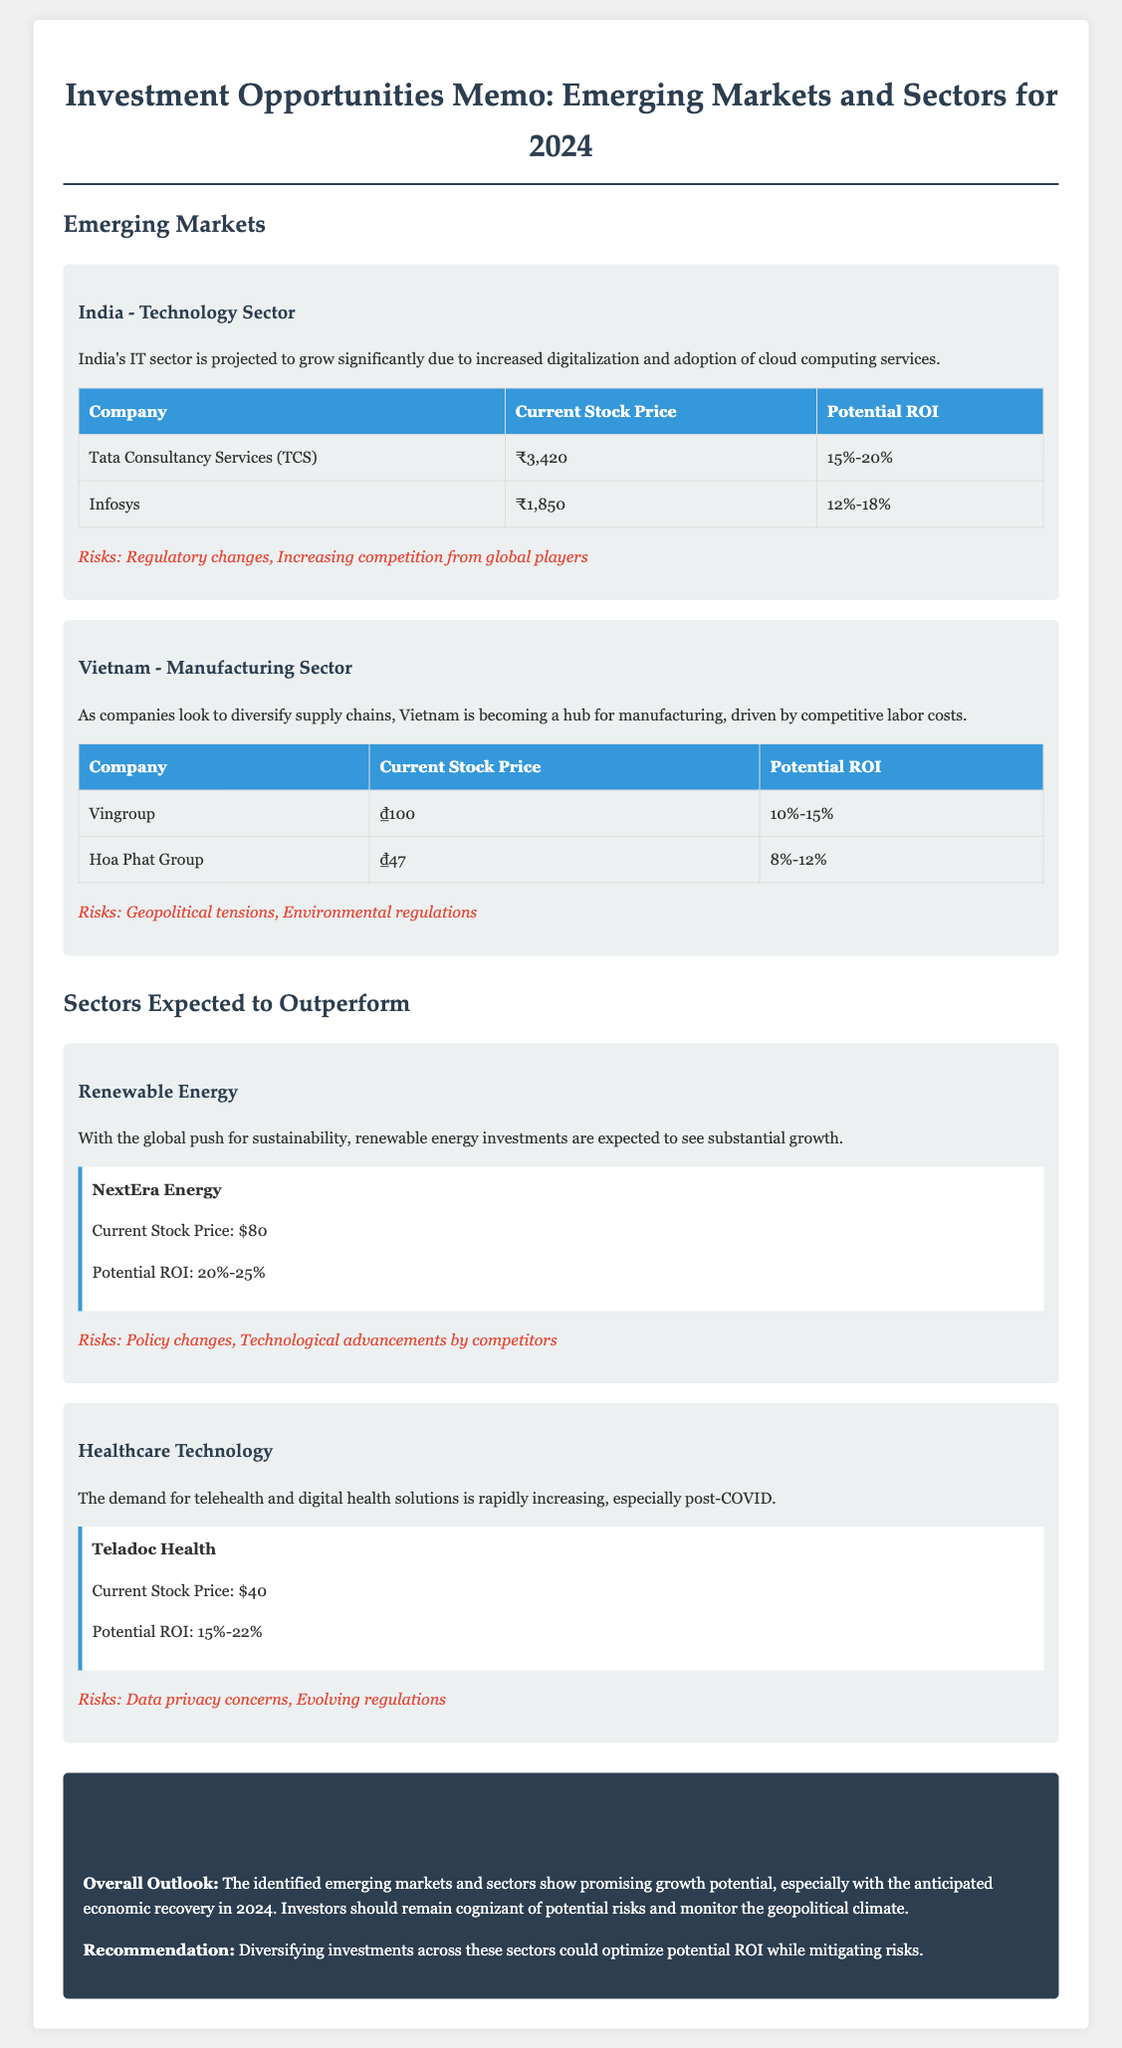What is the projected growth for India's IT sector? The memo states that India's IT sector is projected to grow significantly due to increased digitalization and adoption of cloud computing services.
Answer: Significant What are the potential ROI estimates for Tata Consultancy Services? The document provides a range of potential ROI for Tata Consultancy Services, specifically listed in the table under India's technology sector.
Answer: 15%-20% What company is identified as having a potential ROI of 20%-25% in renewable energy? The memo specifies NextEra Energy as the company with this potential ROI under the renewable energy sector section.
Answer: NextEra Energy What is the current stock price of Vingroup? The current stock price is detailed in the table for the Vietnam manufacturing sector.
Answer: ₫100 What are the identified risks for healthcare technology investments? The memo outlines specific risks associated with healthcare technology investments, particularly noted in the healthcare technology sector section.
Answer: Data privacy concerns, Evolving regulations Which emerging market is highlighted for its manufacturing sector? The memo mentions Vietnam specifically for its focus on manufacturing sector opportunities.
Answer: Vietnam What is the anticipated economic recovery year mentioned in the summary? The memo forecasts economic recovery, providing a specific year for investors to consider in their strategies.
Answer: 2024 What is the potential ROI for Hoa Phat Group? The potential ROI details are included in the table under the Vietnam manufacturing sector.
Answer: 8%-12% 